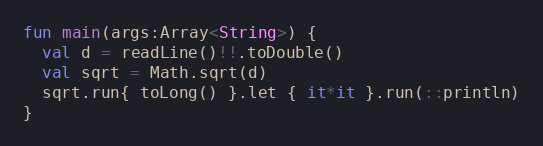<code> <loc_0><loc_0><loc_500><loc_500><_Kotlin_>fun main(args:Array<String>) {
  val d = readLine()!!.toDouble()
  val sqrt = Math.sqrt(d)
  sqrt.run{ toLong() }.let { it*it }.run(::println)
}</code> 